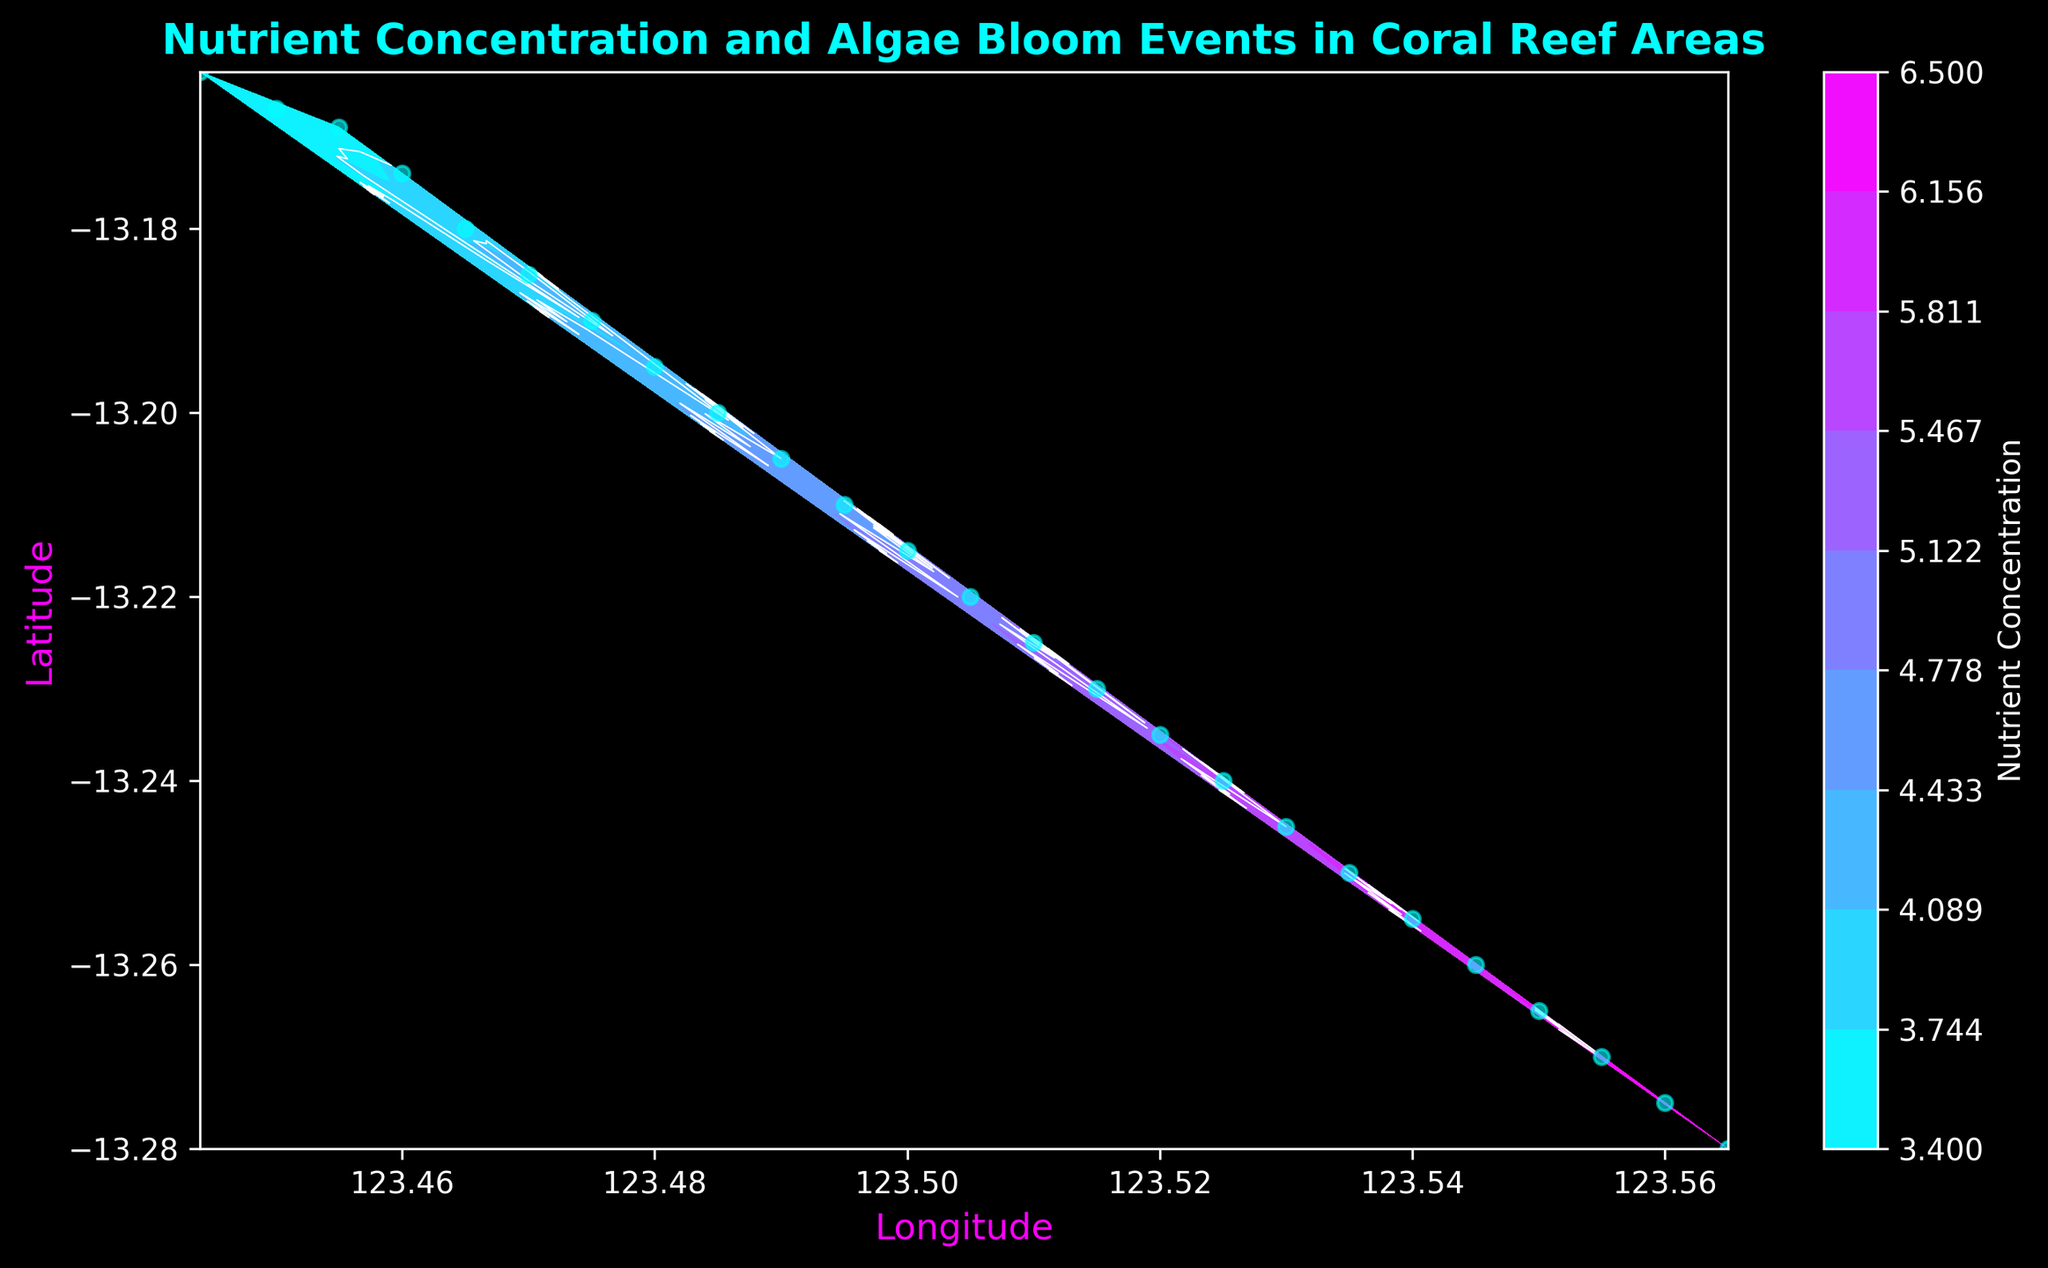How do nutrient concentrations and algae bloom severity trends correlate across the reef area? To determine the correlation, examine both contour plots. Nutrient concentration has a smooth gradient increasing from the bottom left to top right. Algae bloom severity follows a similar pattern, suggesting a positive correlation where higher nutrient concentrations coincide with higher algae bloom severity.
Answer: Positive correlation Which location has the highest algae bloom severity? Look for the peak of the white contour lines that represent algae bloom severity. The highest value appears near the top right corner of the plot at coordinates (-13.280, 123.565).
Answer: (-13.280, 123.565) What is the algae bloom severity level at a nutrient concentration of 5.9? Locate the longitude-latitude point where nutrient concentration contours reach 5.9. This occurs close to (-13.250, 123.535). The corresponding algae bloom contour line is 16.
Answer: 16 Compare the algae bloom severity at nutrient concentrations of 4.2 and 6.1. Which is higher? Locate the positions in the nutrient concentration contour for 4.2 and 6.1. At 4.2 (around (-13.185, 123.470)), the algae bloom severity is 9. At 6.1 (around (-13.260, 123.545)), the severity is 18. Thus, 6.1 has a higher severity.
Answer: 6.1 What is the average nutrient concentration over the reef area displayed? Identify the range of nutrient concentrations by examining the contour plot. The values are equally spread from 3.4 to 6.5. Calculating the average of these boundary values: (3.4 + 6.5) / 2 = 4.95.
Answer: 4.95 How does algae bloom severity change as you move from -13.225 latitude to -13.280 latitude? Trace the white contour lines for algae bloom severity from upper-mid to bottom-right of the plot, from -13.225 to -13.280 latitude. Algae bloom severity increases steadily, from around 13 to 20.
Answer: Increases steadily What is the relationship between longitude and nutrient concentration? Observe the nutrient concentration contours progressing from left to right (increasing longitude). Nutrient concentration increases gradually from around 3.4 at lower longitudes to approximately 6.5 at higher longitudes.
Answer: Linear increase Identify the nutrient concentration range where algae blooms severity sharply increases. Examine where algae bloom severity contours are densely packed. The sharp increase is visible between nutrient concentration levels 5.5 to 6.0, indicating the most rapid change.
Answer: 5.5 to 6.0 What is the nutrient concentration at which algae bloom severity first reaches 15? Find the algae bloom contour labeled 15 and trace it back to the corresponding nutrient concentration. It intersects at around 5.4 nutrient concentration.
Answer: 5.4 Where do nutrient concentration levels exceed 5.7? Nutrient concentration levels exceeding 5.7 are found in the top-right region of the plot, beyond latitude -13.240 and longitude 123.525.
Answer: Top-right region 